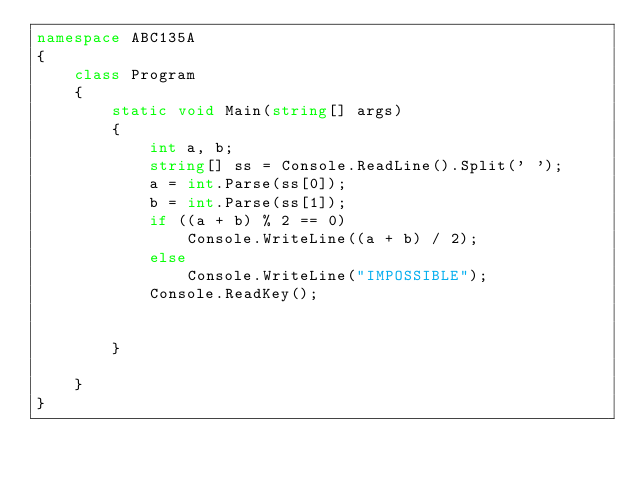Convert code to text. <code><loc_0><loc_0><loc_500><loc_500><_C#_>namespace ABC135A
{
    class Program
    {
        static void Main(string[] args)
        {
            int a, b;
            string[] ss = Console.ReadLine().Split(' ');
            a = int.Parse(ss[0]);
            b = int.Parse(ss[1]);
            if ((a + b) % 2 == 0)
                Console.WriteLine((a + b) / 2);
            else
                Console.WriteLine("IMPOSSIBLE");
            Console.ReadKey();
            

        }

    }
}</code> 